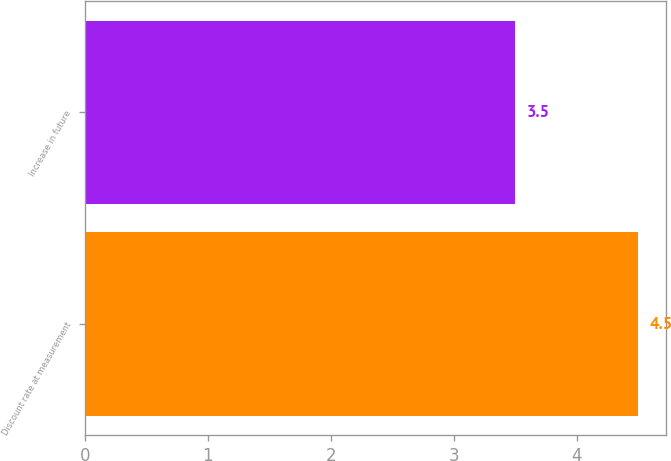Convert chart. <chart><loc_0><loc_0><loc_500><loc_500><bar_chart><fcel>Discount rate at measurement<fcel>Increase in future<nl><fcel>4.5<fcel>3.5<nl></chart> 